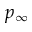Convert formula to latex. <formula><loc_0><loc_0><loc_500><loc_500>p _ { \infty }</formula> 